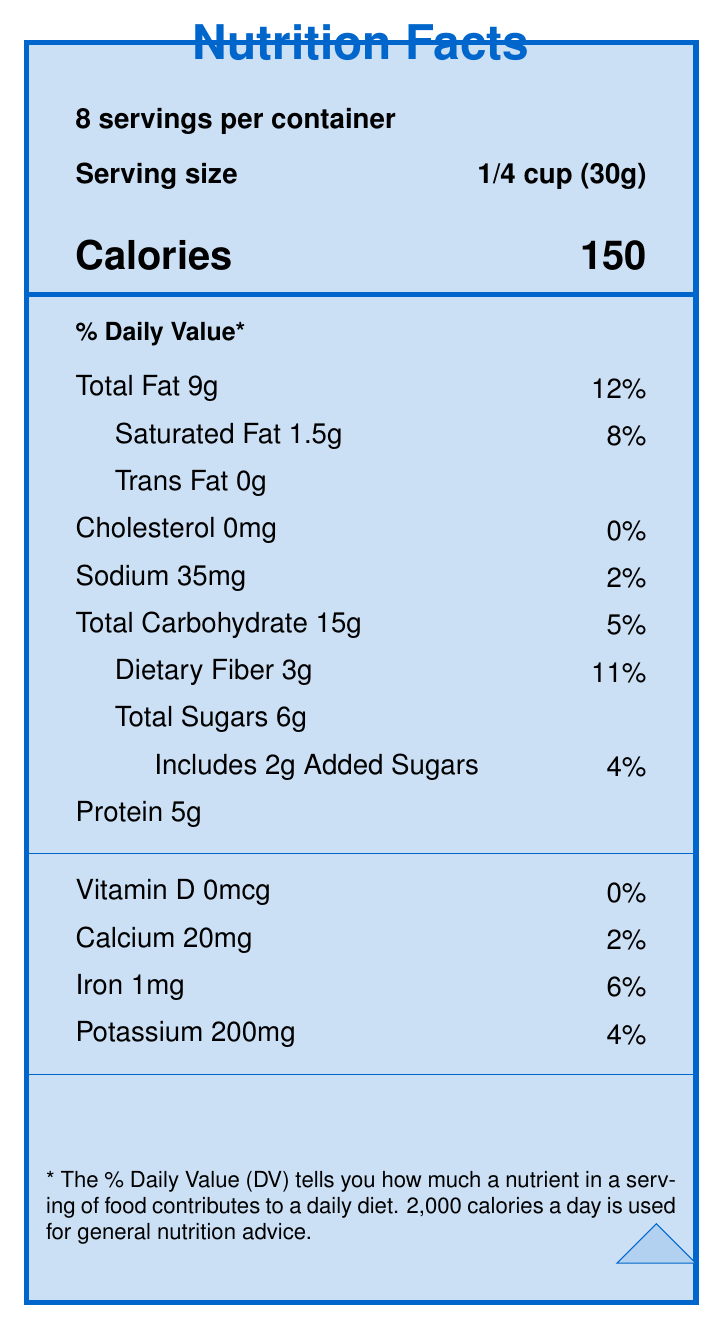what is the serving size of Guitarist's Fuel Organic Trail Mix? The document indicates the serving size as 1/4 cup (30g).
Answer: 1/4 cup (30g) How many calories are in one serving of the trail mix? The document lists the number of calories per serving as 150.
Answer: 150 What is the daily value percentage for total fat in one serving of the trail mix? The document shows that the daily value percentage for total fat is 12%.
Answer: 12% How much sodium is in a serving of Guitarist's Fuel Organic Trail Mix? The document states there are 35mg of sodium per serving.
Answer: 35mg Which ingredient is listed first in the ingredients list? The document lists "Organic almonds" as the first ingredient.
Answer: Organic almonds What amount of dietary fiber is in one serving of the trail mix? The document indicates there are 3g of dietary fiber per serving.
Answer: 3g How much iron does one serving of the trail mix contain? A. 0.5mg B. 1mg C. 2mg D. 5mg The document shows there is 1mg of iron per serving, which corresponds to option B.
Answer: B. 1mg Which of the following certifications does Guitarist's Fuel Organic Trail Mix have? i. USDA Organic ii. Non-GMO Project Verified iii. Fair Trade Certified iv. Gluten-Free The document lists "USDA Organic," "Non-GMO Project Verified," and "Fair Trade Certified" as certifications, but not "Gluten-Free."
Answer: i, ii, iii Is the product marketed as containing tree nuts? The document clearly states that the product "Contains tree nuts."
Answer: Yes Summarize the purpose and nutritional benefits highlighted in the document. The document promotes the Guitarist's Fuel Organic Trail Mix as a nutritionally balanced and guitar-practice-friendly snack. It comprises organic ingredients with various health benefits that support sustained energy and muscle function, necessary for long practice sessions.
Answer: Guitarist's Fuel Organic Trail Mix is designed to provide energy and nutritional support during long guitar practice sessions. It is a locally-sourced, organic product with a balanced combination of fats, protein, and carbohydrates. The ingredients include various nuts, seeds, dried fruits, and dark chocolate. Key nutrients are highlighted, such as dietary fiber, protein, and important minerals like potassium and iron. The mix is also marketed with guitar-related benefits, emphasizing muscle function and reducing finger joint inflammation. What is the company name that manufactures Guitarist's Fuel Organic Trail Mix? The document states the company name as StringMaster Snacks.
Answer: StringMaster Snacks What health benefit is associated with magnesium in the ingredients? The document mentions that magnesium from nuts and seeds supports muscle function, aiding in smoother chord transitions.
Answer: Supports muscle function for smoother chord transitions What is the total carbohydrate content in one serving? The document states that there are 15g of total carbohydrates per serving.
Answer: 15g How much protein does one serving of the trail mix provide? A. 3g B. 4g C. 5g D. 6g The document shows there are 5g of protein per serving, which corresponds to option C.
Answer: C. 5g How much calcium is in one serving of Guitarist's Fuel Organic Trail Mix? The document lists the amount of calcium as 20mg per serving.
Answer: 20mg Does the document provide information about the product’s gluten content? The document does not mention whether the product contains gluten or if it is gluten-free.
Answer: No 